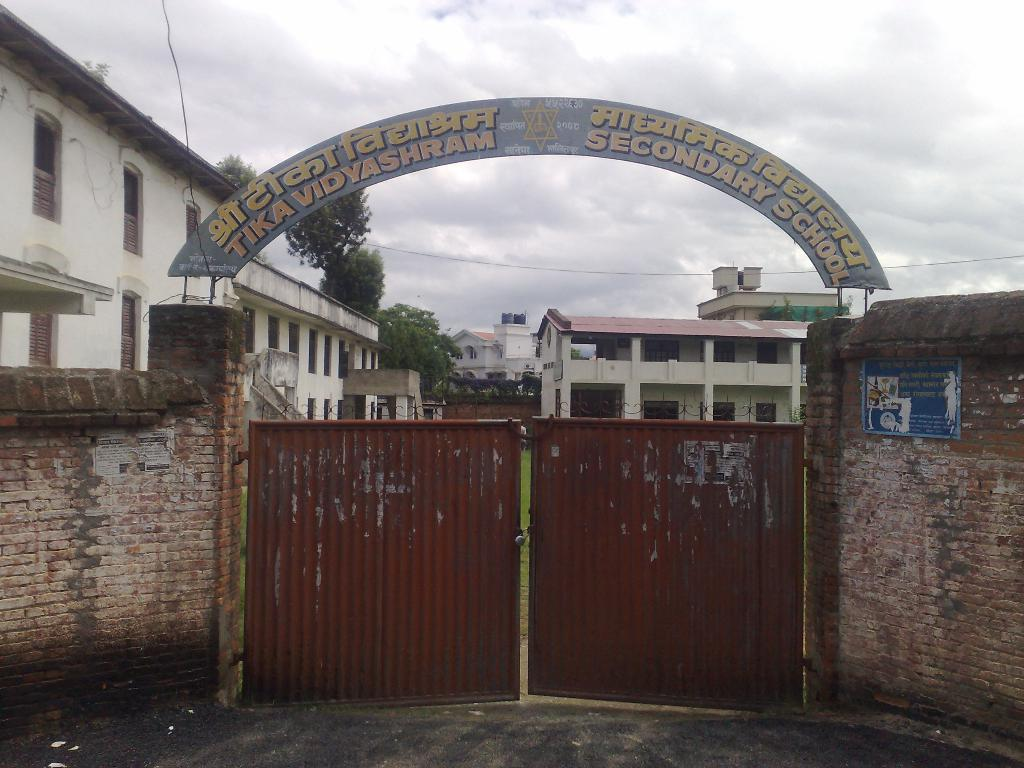What is the main structure visible in the image? There is an entry gate in the image. What color is the entry gate? The entry gate is red in color. What other architectural feature can be seen in the image? There is an arch in the image. What can be seen in the background of the image? There are buildings and a cloudy sky in the background of the image. What surrounds the entry gate? There is a wall on either side of the entry gate. What time of day is it in the image, and how many babies are present? The time of day cannot be determined from the image, and there are no babies present. Is the entry gate a square shape? The shape of the entry gate is not specified in the image, but it is not mentioned as being square. 